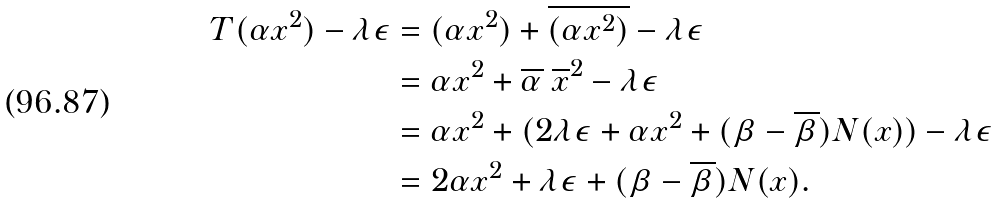<formula> <loc_0><loc_0><loc_500><loc_500>T ( \alpha x ^ { 2 } ) - \lambda \epsilon & = ( \alpha x ^ { 2 } ) + \overline { ( \alpha x ^ { 2 } ) } - \lambda \epsilon \\ & = \alpha x ^ { 2 } + \overline { \alpha } \ \overline { x } ^ { 2 } - \lambda \epsilon \\ & = \alpha x ^ { 2 } + ( 2 \lambda \epsilon + \alpha x ^ { 2 } + ( \beta - \overline { \beta } ) N ( x ) ) - \lambda \epsilon \\ & = 2 \alpha x ^ { 2 } + \lambda \epsilon + ( \beta - \overline { \beta } ) N ( x ) .</formula> 